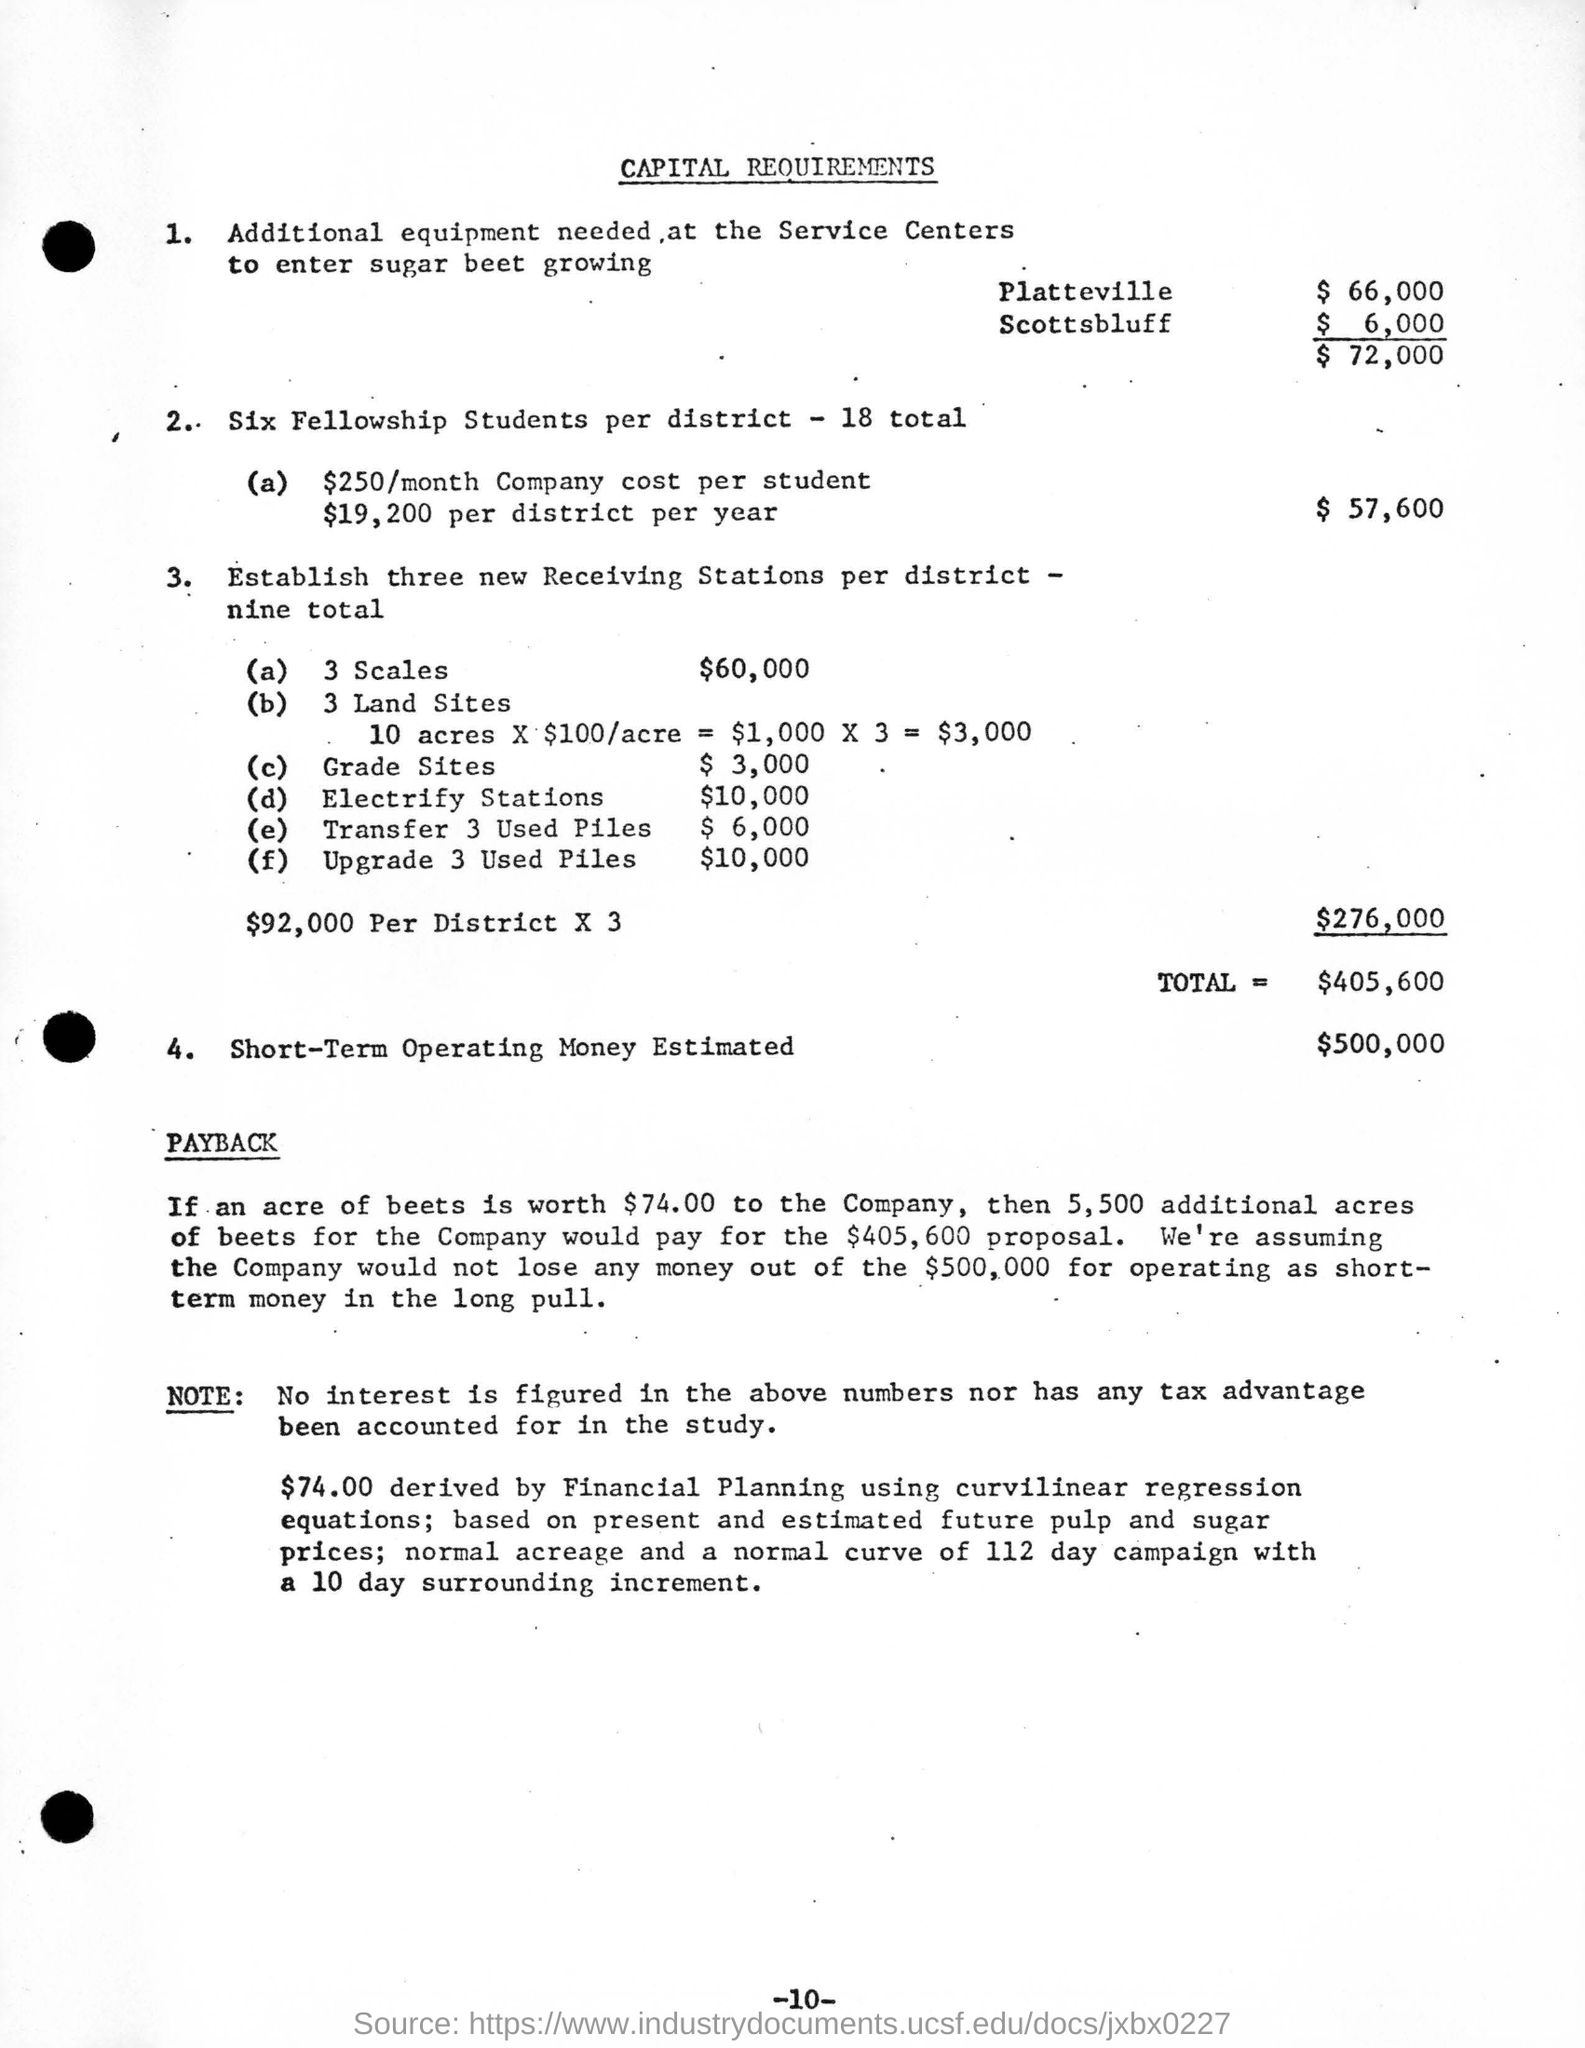Outline some significant characteristics in this image. Six fellowship students are present in each district. The total cost of purchasing the necessary equipment for the service centers to enter the sugar beet growing industry is approximately $72,000. The amount derived from financial planning is $74.00. The monthly cost per student for the company is $250. The estimated short-term operating expenses for the next year are approximately $500,000. 